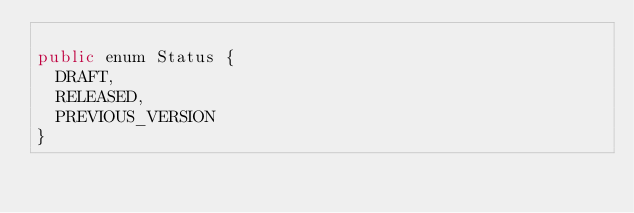<code> <loc_0><loc_0><loc_500><loc_500><_Java_>
public enum Status {
  DRAFT,
  RELEASED,
  PREVIOUS_VERSION
}
</code> 